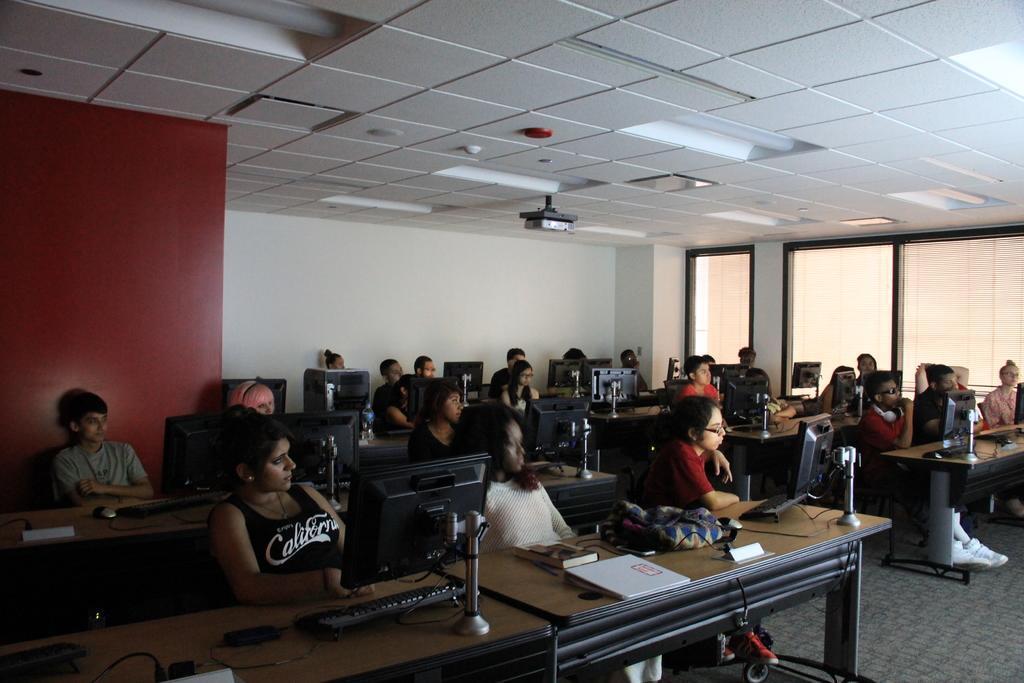Describe this image in one or two sentences. In this room many people are sitting on chairs in front of them on table there are desktops. On few tables there are bags and books. On the top there is ceiling and projector. In the background there is wall. In the right there are windows made up of glass. In the floor there is carpet. 